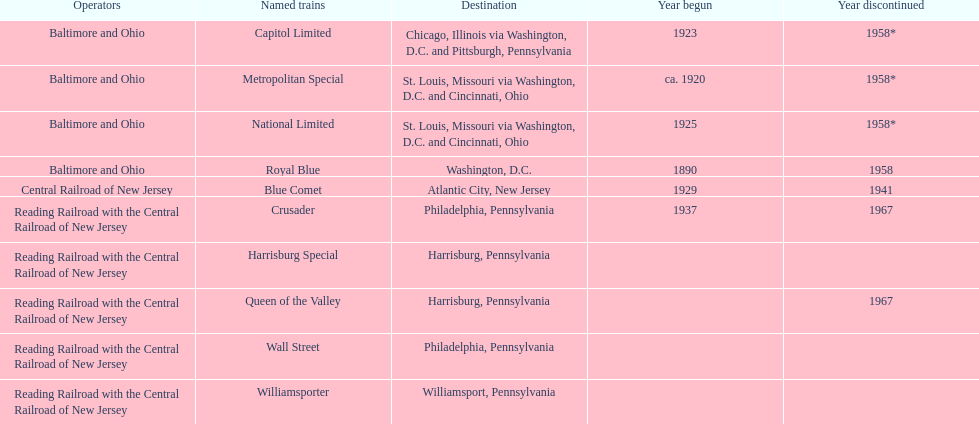What destination is at the top of the list? Chicago, Illinois via Washington, D.C. and Pittsburgh, Pennsylvania. 